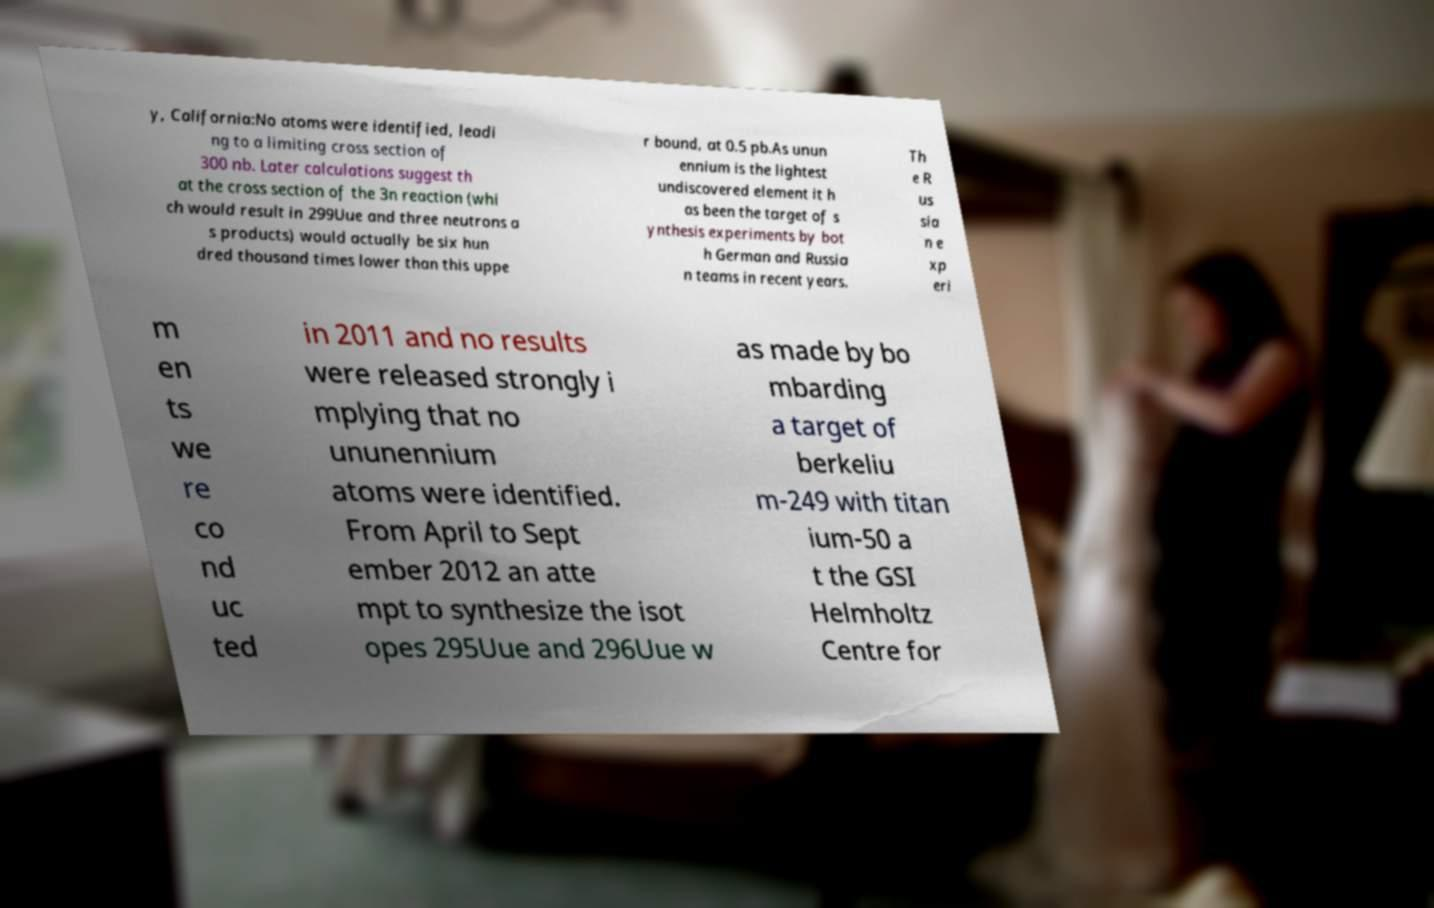I need the written content from this picture converted into text. Can you do that? y, California:No atoms were identified, leadi ng to a limiting cross section of 300 nb. Later calculations suggest th at the cross section of the 3n reaction (whi ch would result in 299Uue and three neutrons a s products) would actually be six hun dred thousand times lower than this uppe r bound, at 0.5 pb.As unun ennium is the lightest undiscovered element it h as been the target of s ynthesis experiments by bot h German and Russia n teams in recent years. Th e R us sia n e xp eri m en ts we re co nd uc ted in 2011 and no results were released strongly i mplying that no ununennium atoms were identified. From April to Sept ember 2012 an atte mpt to synthesize the isot opes 295Uue and 296Uue w as made by bo mbarding a target of berkeliu m-249 with titan ium-50 a t the GSI Helmholtz Centre for 